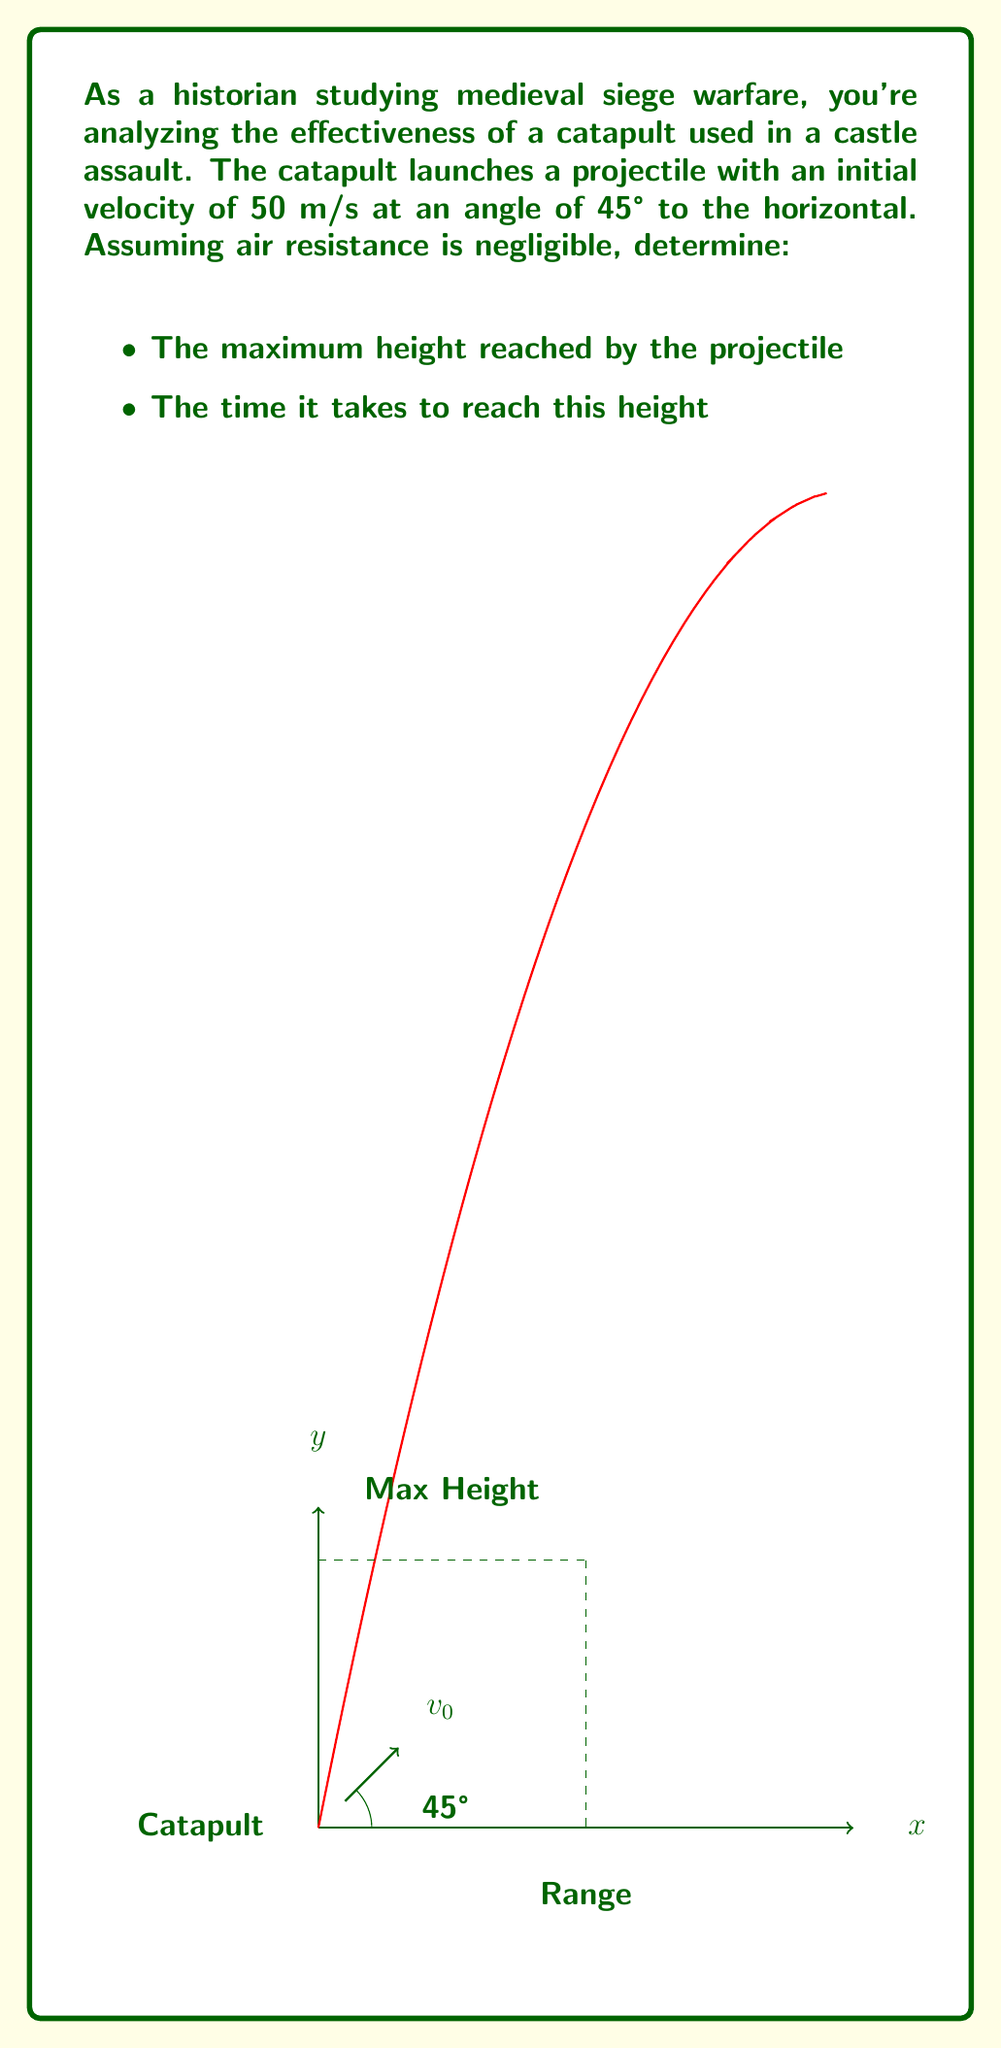What is the answer to this math problem? To solve this problem, we'll use the equations of motion for projectile motion. Let's break it down step-by-step:

1) First, let's recall the relevant equations:
   $$v_y = v_0 \sin \theta - gt$$
   $$y = v_0 \sin \theta \cdot t - \frac{1}{2}gt^2$$

   Where $v_0$ is the initial velocity, $\theta$ is the launch angle, $g$ is the acceleration due to gravity (9.8 m/s²), and $t$ is time.

2) To find the maximum height, we need to find when the vertical velocity ($v_y$) is zero:
   $$0 = v_0 \sin \theta - gt_{max}$$
   $$t_{max} = \frac{v_0 \sin \theta}{g}$$

3) Substituting the given values:
   $$t_{max} = \frac{50 \cdot \sin 45°}{9.8} \approx 3.61 \text{ seconds}$$

4) Now, to find the maximum height, we substitute this time into the equation for y:
   $$h_{max} = v_0 \sin \theta \cdot t_{max} - \frac{1}{2}g{t_{max}}^2$$

5) We can simplify this using the identity $\sin 45° = \frac{1}{\sqrt{2}}$:
   $$h_{max} = \frac{v_0^2 \sin^2 \theta}{2g}$$

6) Substituting the values:
   $$h_{max} = \frac{50^2 \cdot (\frac{1}{\sqrt{2}})^2}{2 \cdot 9.8} \approx 63.78 \text{ meters}$$

Therefore, the projectile reaches a maximum height of approximately 63.78 meters after about 3.61 seconds.
Answer: Maximum height: 63.78 m, Time to reach maximum height: 3.61 s 